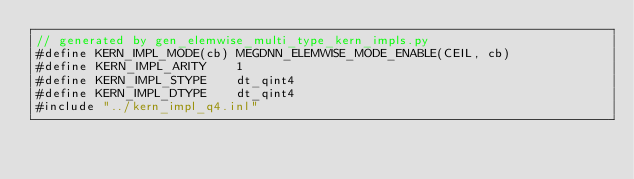<code> <loc_0><loc_0><loc_500><loc_500><_Cuda_>// generated by gen_elemwise_multi_type_kern_impls.py
#define KERN_IMPL_MODE(cb) MEGDNN_ELEMWISE_MODE_ENABLE(CEIL, cb)
#define KERN_IMPL_ARITY    1
#define KERN_IMPL_STYPE    dt_qint4
#define KERN_IMPL_DTYPE    dt_qint4
#include "../kern_impl_q4.inl"
</code> 